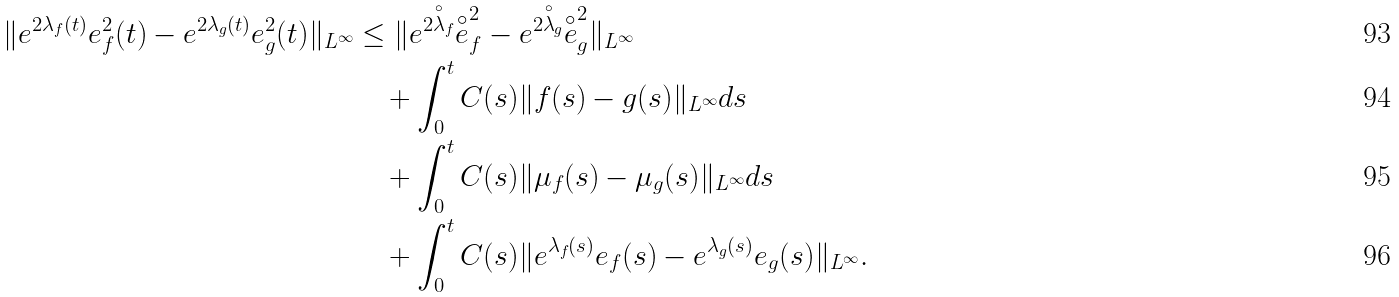<formula> <loc_0><loc_0><loc_500><loc_500>\| e ^ { 2 \lambda _ { f } ( t ) } e _ { f } ^ { 2 } ( t ) - e ^ { 2 \lambda _ { g } ( t ) } e _ { g } ^ { 2 } ( t ) \| _ { L ^ { \infty } } & \leq \| e ^ { 2 \overset { \circ } { \lambda } _ { f } } \overset { \circ } { e } _ { f } ^ { 2 } - e ^ { 2 \overset { \circ } { \lambda } _ { g } } \overset { \circ } { e } _ { g } ^ { 2 } \| _ { L ^ { \infty } } \\ & \quad + \int _ { 0 } ^ { t } C ( s ) \| f ( s ) - g ( s ) \| _ { L ^ { \infty } } d s \\ & \quad + \int _ { 0 } ^ { t } C ( s ) \| \mu _ { f } ( s ) - \mu _ { g } ( s ) \| _ { L ^ { \infty } } d s \\ & \quad + \int _ { 0 } ^ { t } C ( s ) \| e ^ { \lambda _ { f } ( s ) } e _ { f } ( s ) - e ^ { \lambda _ { g } ( s ) } e _ { g } ( s ) \| _ { L ^ { \infty } } .</formula> 